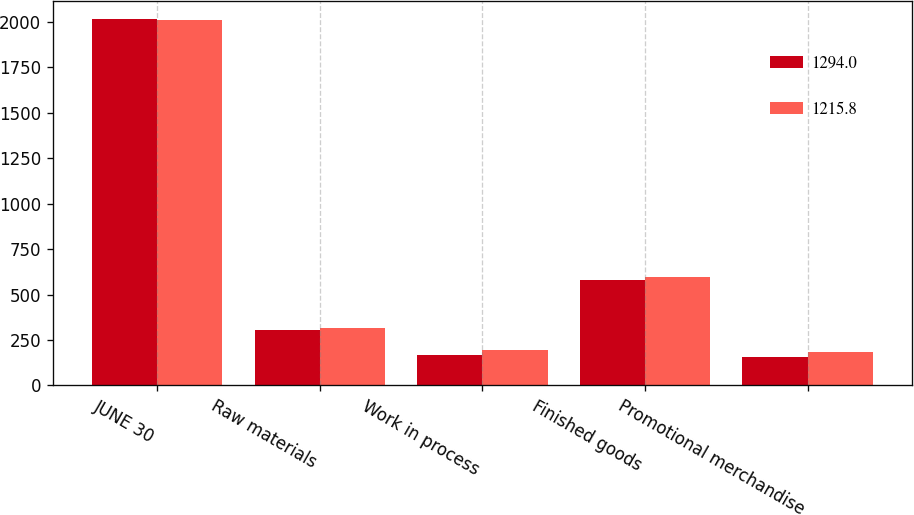Convert chart to OTSL. <chart><loc_0><loc_0><loc_500><loc_500><stacked_bar_chart><ecel><fcel>JUNE 30<fcel>Raw materials<fcel>Work in process<fcel>Finished goods<fcel>Promotional merchandise<nl><fcel>1294<fcel>2015<fcel>306.9<fcel>168.7<fcel>581.3<fcel>158.9<nl><fcel>1215.8<fcel>2014<fcel>317.5<fcel>192.4<fcel>599.5<fcel>184.6<nl></chart> 